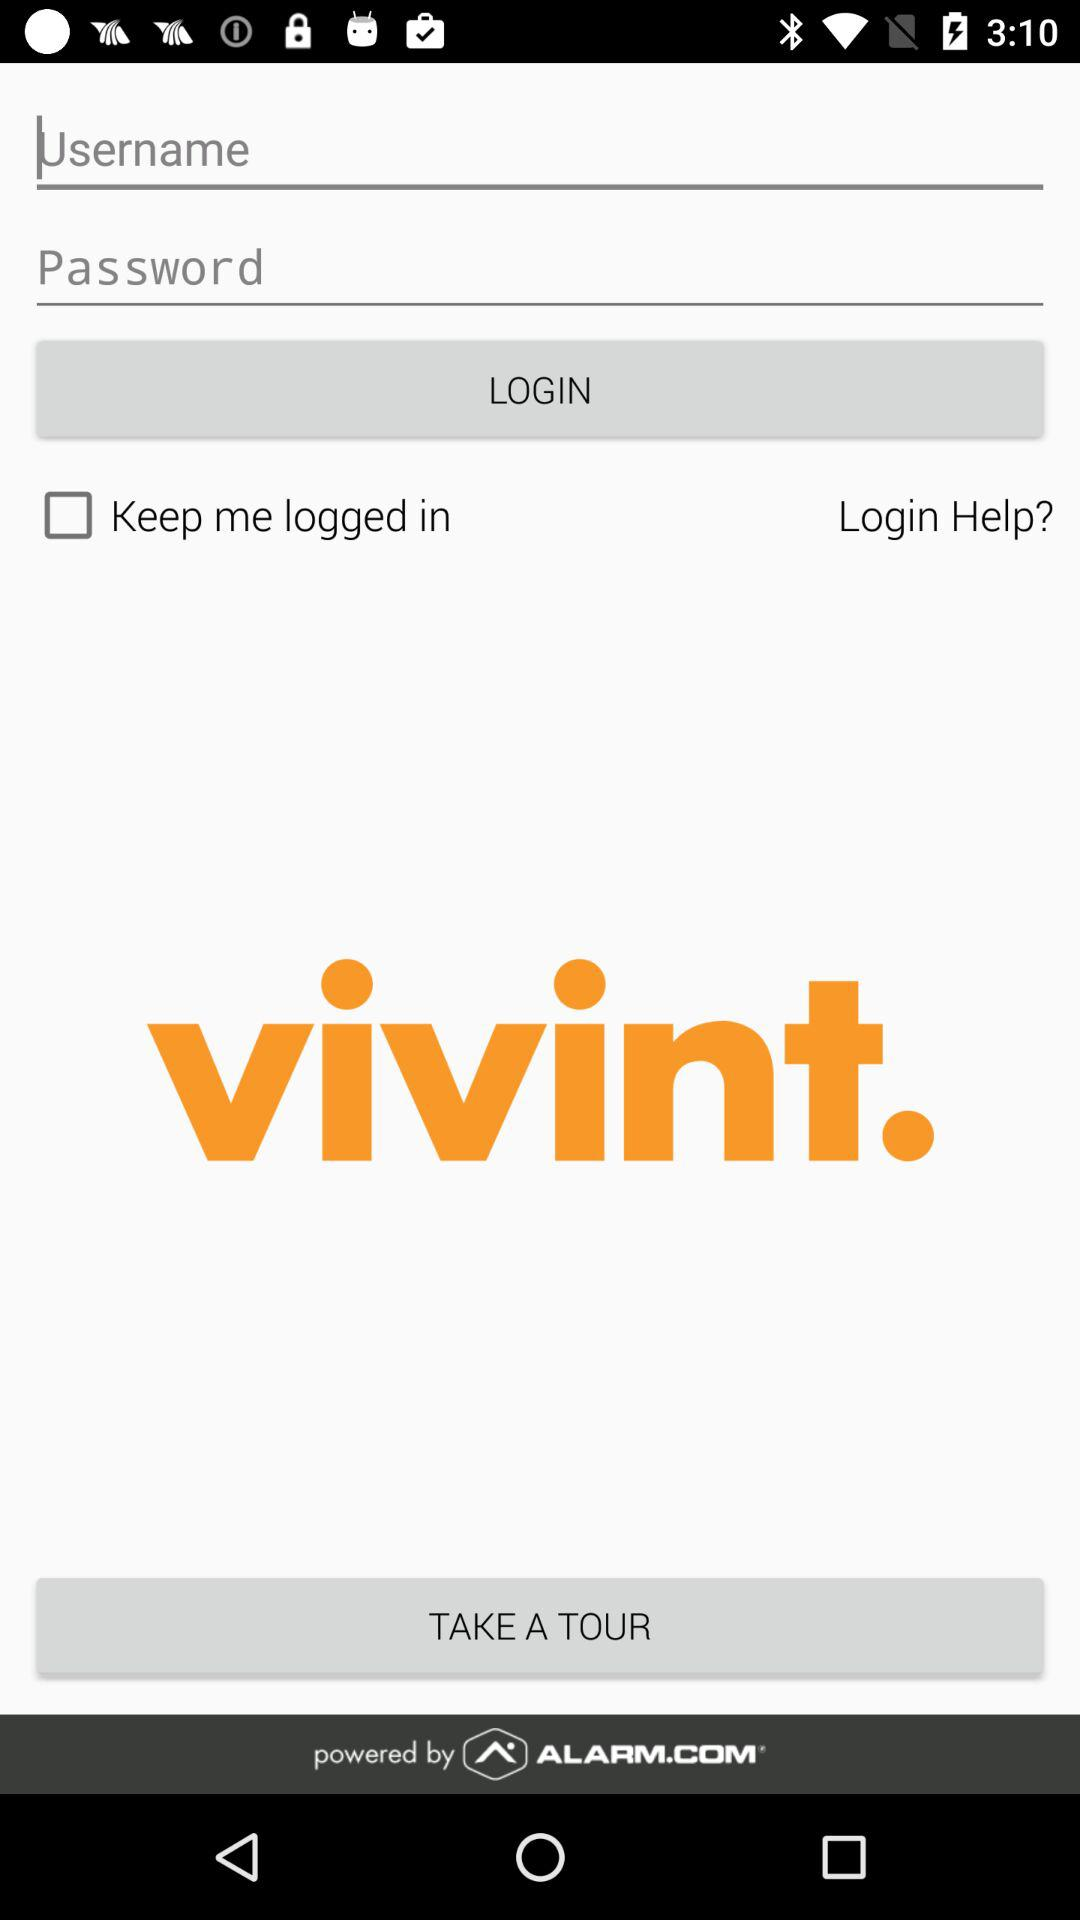What's the status of the "Keep me logged in"? The status is "off". 